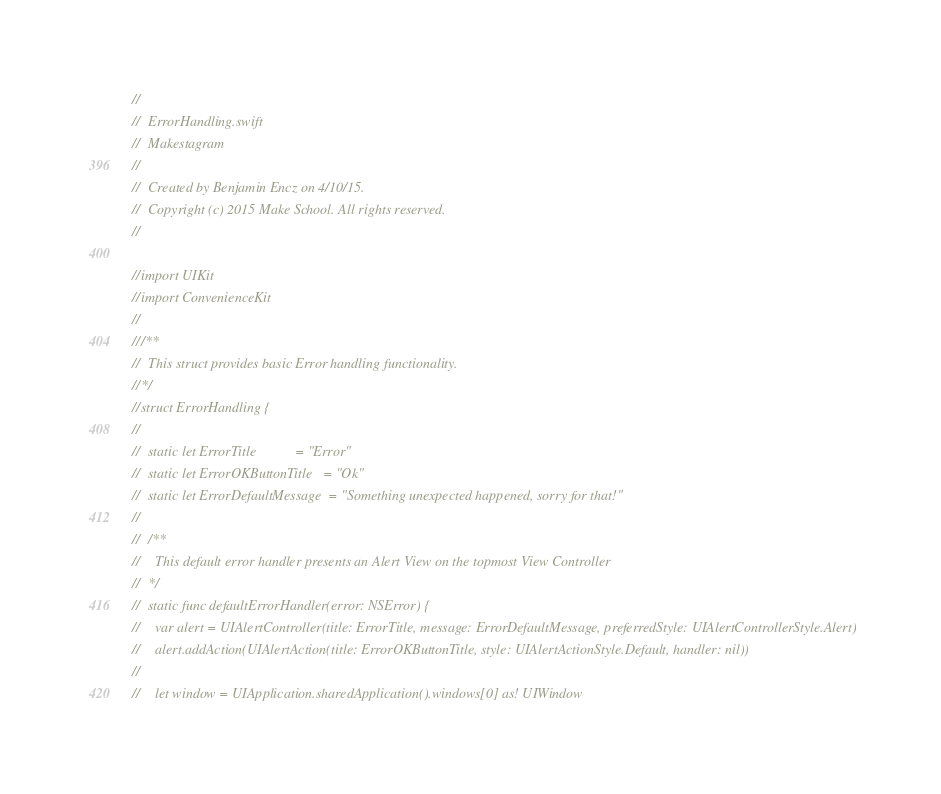<code> <loc_0><loc_0><loc_500><loc_500><_Swift_>//
//  ErrorHandling.swift
//  Makestagram
//
//  Created by Benjamin Encz on 4/10/15.
//  Copyright (c) 2015 Make School. All rights reserved.
//

//import UIKit
//import ConvenienceKit
//
///**
//  This struct provides basic Error handling functionality.
//*/
//struct ErrorHandling {
//  
//  static let ErrorTitle           = "Error"
//  static let ErrorOKButtonTitle   = "Ok"
//  static let ErrorDefaultMessage  = "Something unexpected happened, sorry for that!"
//  
//  /** 
//    This default error handler presents an Alert View on the topmost View Controller 
//  */
//  static func defaultErrorHandler(error: NSError) {
//    var alert = UIAlertController(title: ErrorTitle, message: ErrorDefaultMessage, preferredStyle: UIAlertControllerStyle.Alert)
//    alert.addAction(UIAlertAction(title: ErrorOKButtonTitle, style: UIAlertActionStyle.Default, handler: nil))
//    
//    let window = UIApplication.sharedApplication().windows[0] as! UIWindow</code> 